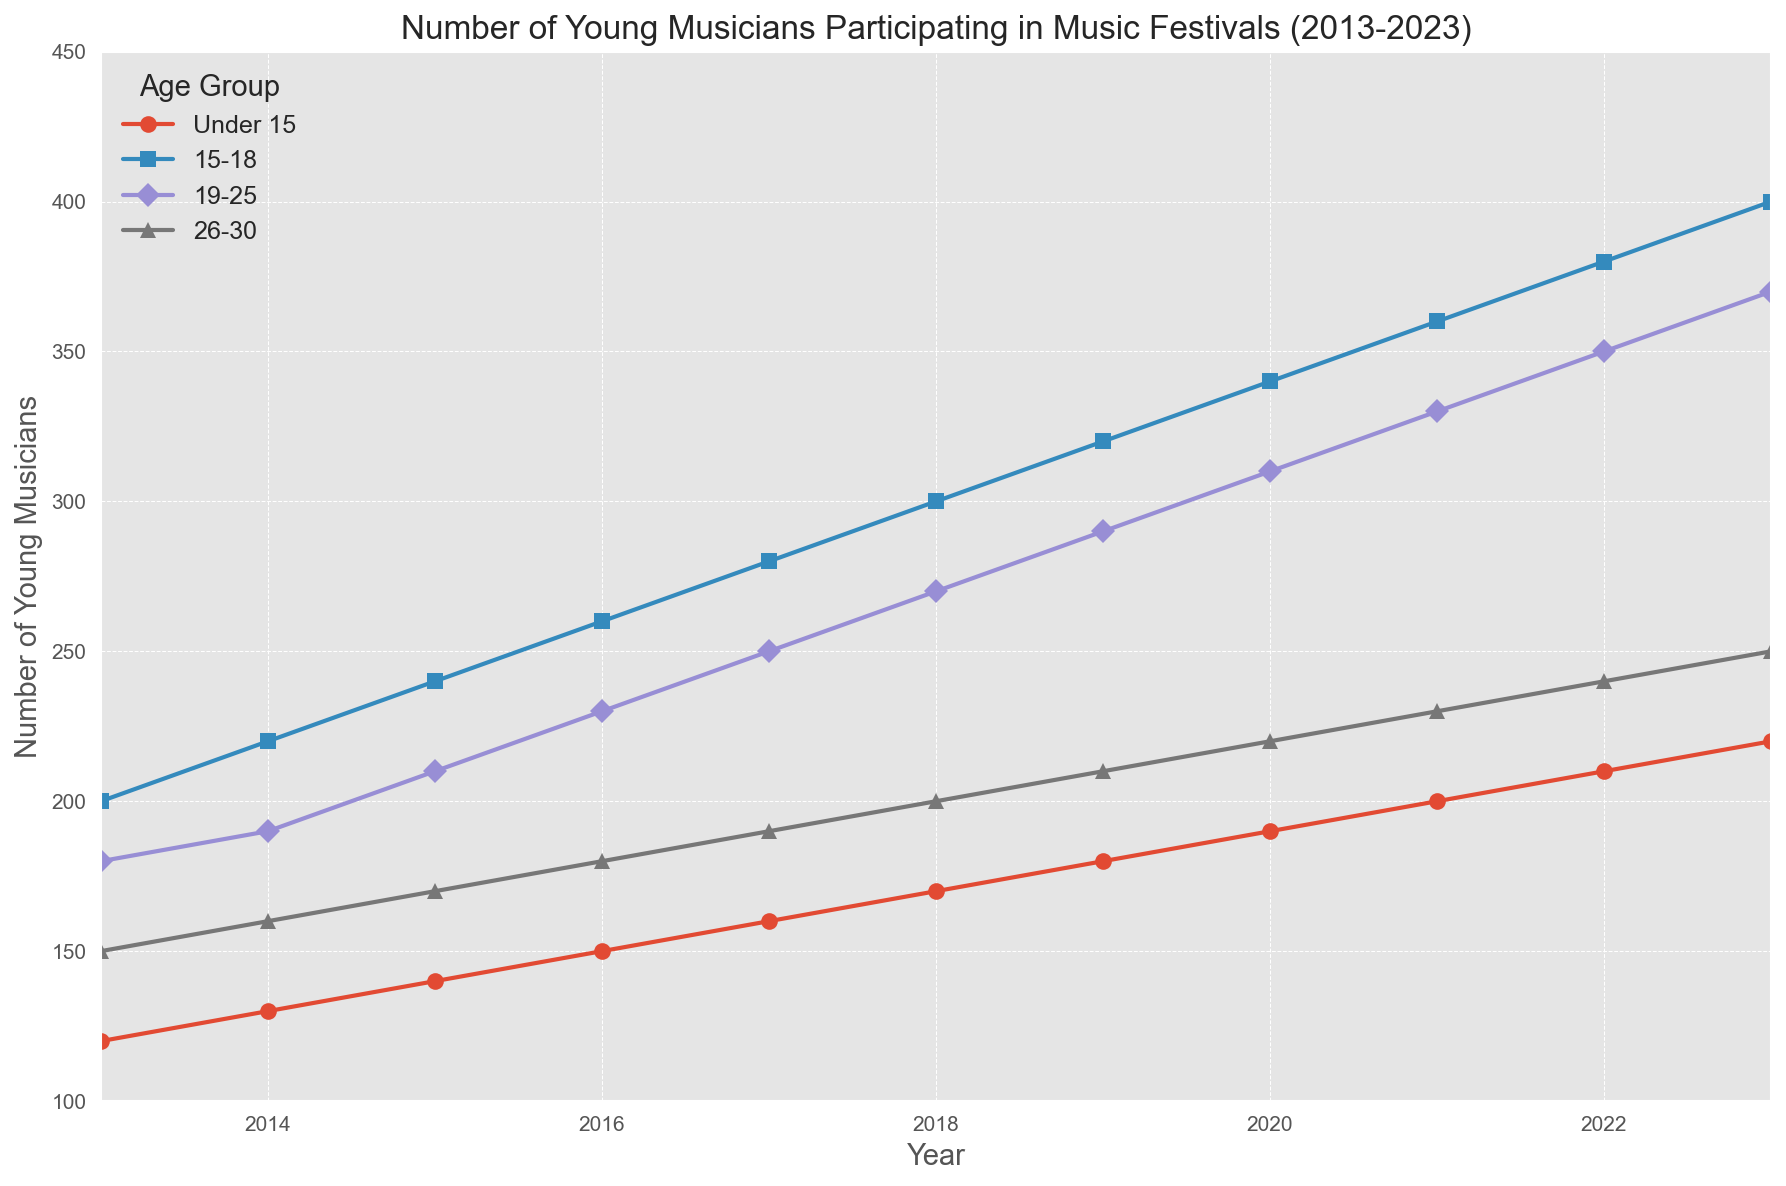How has the number of musicians aged 19-25 changed from 2013 to 2023? To determine the change, subtract the value in 2013 from the value in 2023 for the 19-25 age group. The number in 2013 is 180 and in 2023 is 370, so the change is 370 - 180 = 190.
Answer: 190 Which age group had the highest increase in participation over the time period shown? Calculate the increase for each age group by subtracting the 2013 value from the 2023 value. Under 15: 220-120=100, 15-18: 400-200=200, 19-25: 370-180=190, 26-30: 250-150=100. The 15-18 age group had the highest increase with 200 participants.
Answer: 15-18 In which year did the number of musicians under 15 surpass 200? Look at the 'Under 15' data and find the first year where the value exceeds 200. The value surpasses 200 in 2021 (190 in 2020, 200 in 2021).
Answer: 2021 What is the average number of participants aged 26-30 across all the years? Sum the 26-30 values and divide by the number of years (11). (150+160+170+180+190+200+210+220+230+240+250)/11 = 2100/11 ≈ 190.91.
Answer: 190.91 Compare the number of 15-18-year-old musicians in 2020 with the number of under 15 musicians in 2023. Which group had more participants? Compare the data values: 15-18 in 2020 is 340, and Under 15 in 2023 is 220. 340 is greater than 220, so the 15-18 group in 2020 had more participants.
Answer: 15-18 in 2020 What is the combined number of musicians in all age groups for the year 2017? Sum the values for all age groups in 2017. Under 15: 160, 15-18: 280, 19-25: 250, 26-30: 190. Total = 160 + 280 + 250 + 190 = 880.
Answer: 880 By how much did the number of 15-18-year-old musicians increase from 2015 to 2019? Subtract the 2015 value from the 2019 value for the 15-18 age group. 320 (2019) - 240 (2015) = 80.
Answer: 80 Which age group has the most consistent growth over the decade? Evaluate the growth trends by observing the lines' slopes over the years. The Under 15 and 15-18 age groups show the most consistent linear growth without significant fluctuations. Both increase steadily every year.
Answer: Under 15 and 15-18 What is the difference between the highest and lowest number of musicians in the 19–25 age group in the given years? Identify the highest and lowest values for the 19-25 age group. Highest: 370 (2023), Lowest: 180 (2013). Difference = 370 - 180 = 190.
Answer: 190 How many years did it take for the number of musicians under 15 to go from 120 to 220? Subtract the initial year from the final year when the under 15 numbers were 120 and 220 respectively. Initial year: 2013, Final year: 2023. 2023 - 2013 = 10 years.
Answer: 10 